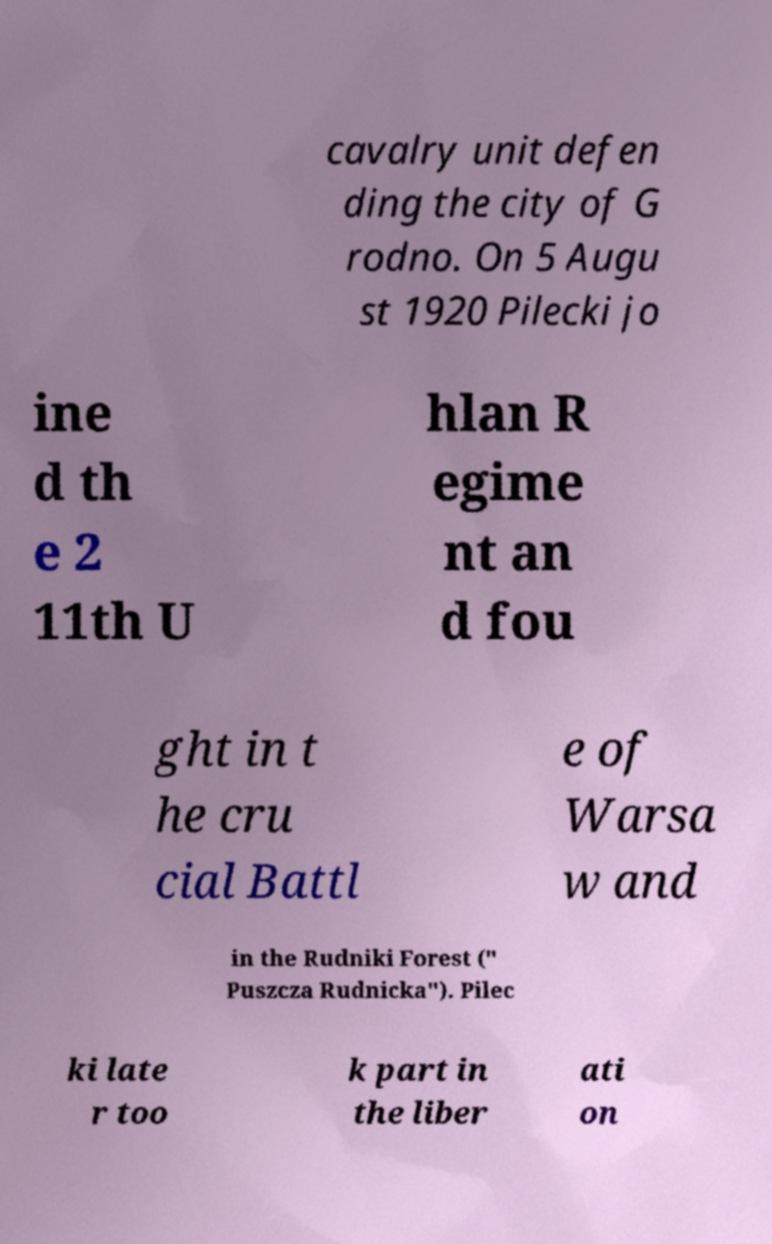Please identify and transcribe the text found in this image. cavalry unit defen ding the city of G rodno. On 5 Augu st 1920 Pilecki jo ine d th e 2 11th U hlan R egime nt an d fou ght in t he cru cial Battl e of Warsa w and in the Rudniki Forest (" Puszcza Rudnicka"). Pilec ki late r too k part in the liber ati on 